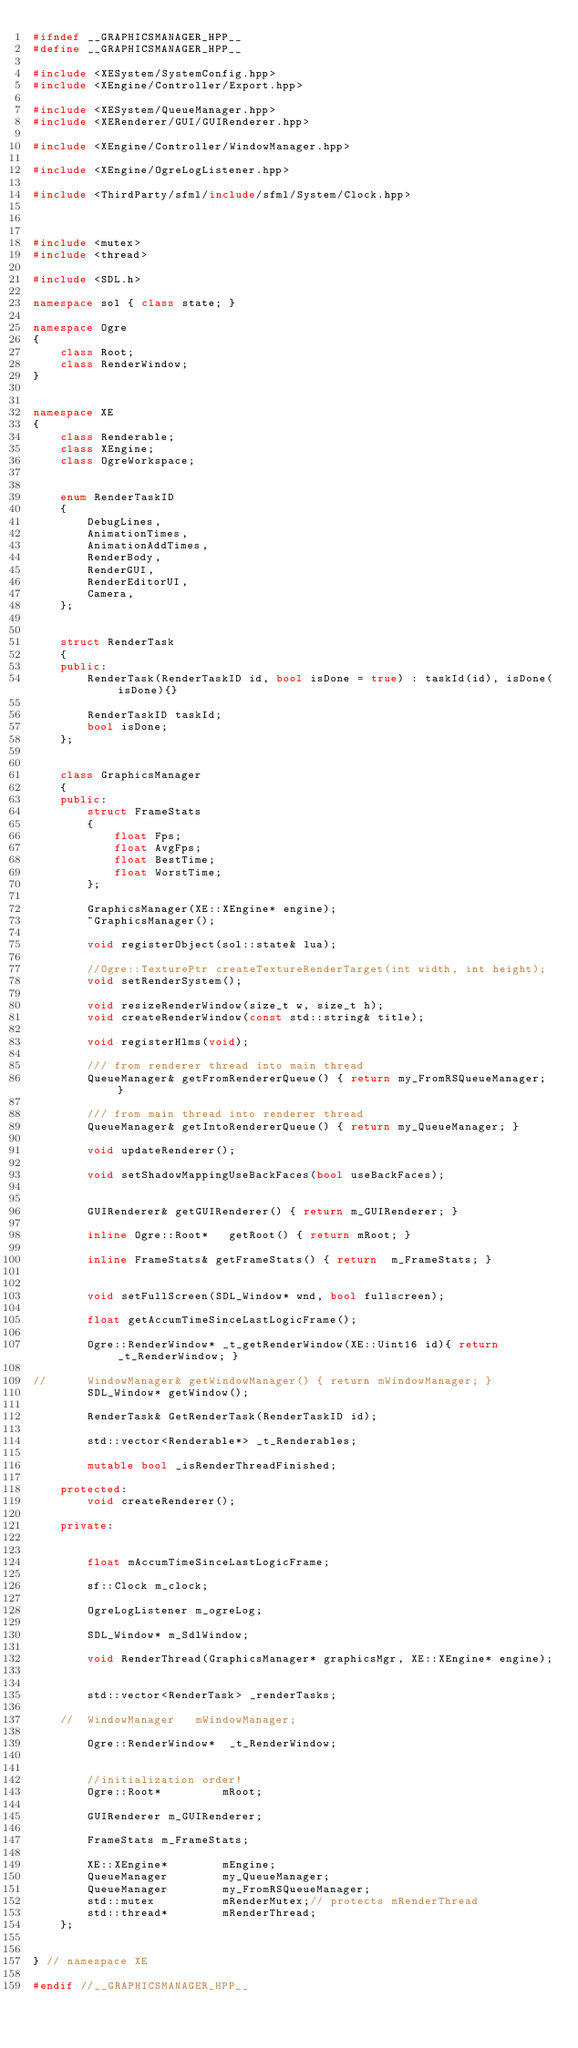<code> <loc_0><loc_0><loc_500><loc_500><_C++_>#ifndef __GRAPHICSMANAGER_HPP__
#define __GRAPHICSMANAGER_HPP__

#include <XESystem/SystemConfig.hpp>
#include <XEngine/Controller/Export.hpp>

#include <XESystem/QueueManager.hpp>
#include <XERenderer/GUI/GUIRenderer.hpp>

#include <XEngine/Controller/WindowManager.hpp>

#include <XEngine/OgreLogListener.hpp>

#include <ThirdParty/sfml/include/sfml/System/Clock.hpp>



#include <mutex>
#include <thread>

#include <SDL.h>

namespace sol { class state; }

namespace Ogre
{
	class Root;
	class RenderWindow;
}


namespace XE
{
	class Renderable;
	class XEngine;
	class OgreWorkspace;


	enum RenderTaskID
	{
		DebugLines,
		AnimationTimes,
		AnimationAddTimes,
		RenderBody,
		RenderGUI,
		RenderEditorUI,
		Camera,
	};


	struct RenderTask
	{
	public:
		RenderTask(RenderTaskID id, bool isDone = true) : taskId(id), isDone(isDone){}

		RenderTaskID taskId;
		bool isDone;
	};


	class GraphicsManager 
	{
	public:
		struct FrameStats
		{
			float Fps;
			float AvgFps;
			float BestTime;
			float WorstTime;
		};

		GraphicsManager(XE::XEngine* engine);
		~GraphicsManager();

		void registerObject(sol::state& lua);

		//Ogre::TexturePtr createTextureRenderTarget(int width, int height);
		void setRenderSystem();
		
		void resizeRenderWindow(size_t w, size_t h);
		void createRenderWindow(const std::string& title);
		
		void registerHlms(void);

		/// from renderer thread into main thread
		QueueManager& getFromRendererQueue() { return my_FromRSQueueManager; }

		/// from main thread into renderer thread
		QueueManager& getIntoRendererQueue() { return my_QueueManager; }

		void updateRenderer();

		void setShadowMappingUseBackFaces(bool useBackFaces);


		GUIRenderer& getGUIRenderer() { return m_GUIRenderer; }

		inline Ogre::Root*	 getRoot() { return mRoot; }

		inline FrameStats& getFrameStats() { return  m_FrameStats; }
		

		void setFullScreen(SDL_Window* wnd, bool fullscreen);

		float getAccumTimeSinceLastLogicFrame();

		Ogre::RenderWindow* _t_getRenderWindow(XE::Uint16 id){ return _t_RenderWindow; }

//		WindowManager& getWindowManager() { return mWindowManager; }
		SDL_Window* getWindow();

		RenderTask& GetRenderTask(RenderTaskID id);

		std::vector<Renderable*> _t_Renderables;
		
		mutable bool _isRenderThreadFinished;

	protected:
		void createRenderer();

	private:

		
		float mAccumTimeSinceLastLogicFrame;
		
		sf::Clock m_clock;

		OgreLogListener m_ogreLog;

		SDL_Window* m_SdlWindow;

		void RenderThread(GraphicsManager* graphicsMgr, XE::XEngine* engine);


		std::vector<RenderTask> _renderTasks;

	//	WindowManager	mWindowManager;

		Ogre::RenderWindow*  _t_RenderWindow;
	

		//initialization order!
		Ogre::Root*			mRoot;

		GUIRenderer m_GUIRenderer;
		
		FrameStats m_FrameStats;

		XE::XEngine*		mEngine;
		QueueManager		my_QueueManager;
		QueueManager		my_FromRSQueueManager;
		std::mutex			mRenderMutex;// protects mRenderThread
		std::thread*		mRenderThread;
	};


} // namespace XE

#endif //__GRAPHICSMANAGER_HPP__</code> 